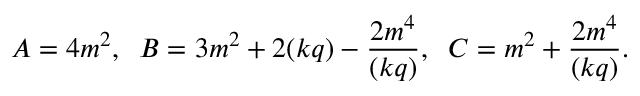<formula> <loc_0><loc_0><loc_500><loc_500>A = 4 m ^ { 2 } , \, B = 3 m ^ { 2 } + 2 ( k q ) - { \frac { 2 m ^ { 4 } } { ( k q ) } } , \, C = m ^ { 2 } + { \frac { 2 m ^ { 4 } } { ( k q ) } } .</formula> 